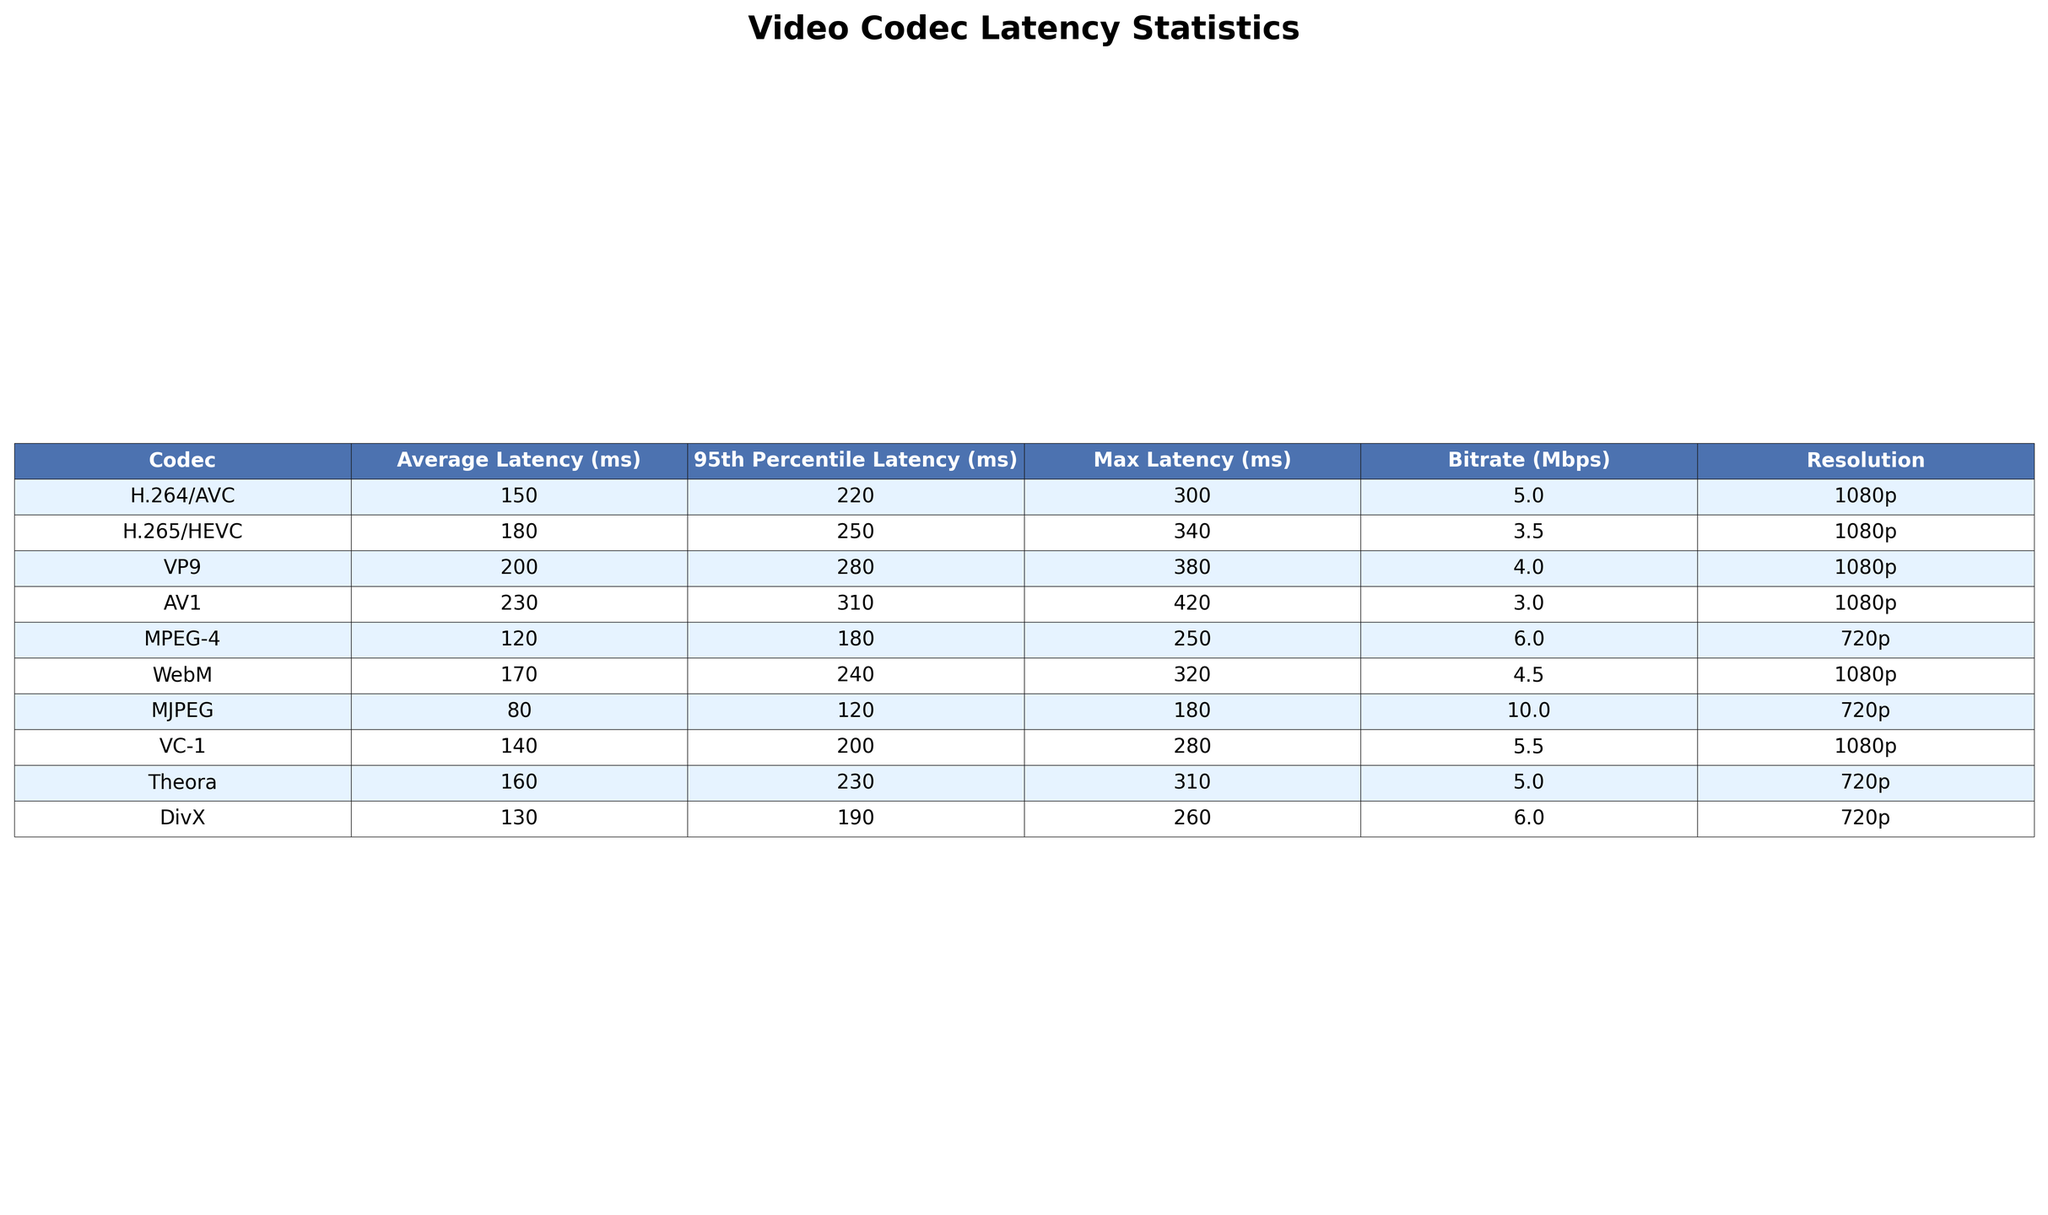What is the average latency of the H.265 codec? The average latency for the H.265 codec is provided in the table under the 'Average Latency (ms)' column. It is listed as 180 ms.
Answer: 180 ms Which codec has the maximum latency among the listed codecs? The maximum latency for each codec is listed under the 'Max Latency (ms)' column. The highest value is 420 ms, which corresponds to the AV1 codec.
Answer: AV1 What is the difference in average latency between H.264 and VP9? The average latency for H.264 is 150 ms, and for VP9, it is 200 ms. The difference is 200 ms - 150 ms = 50 ms.
Answer: 50 ms Is the average latency of the WebM codec less than 200 ms? The average latency for the WebM codec is 170 ms, which is less than 200 ms, so the answer is true.
Answer: Yes Which codec shows the highest 95th percentile latency? The '95th Percentile Latency (ms)' column shows that AV1 has the highest value of 310 ms.
Answer: AV1 What is the average bitrate of all the codecs listed in the table? First, we sum all the bitrates: 5 + 3.5 + 4 + 3 + 6 + 4.5 + 10 + 5.5 + 5 + 6 = 58. Then we divide by the number of codecs, which is 10. Thus, the average bitrate is 58 / 10 = 5.8 Mbps.
Answer: 5.8 Mbps Which codecs have a maximum latency greater than 300 ms? We check the 'Max Latency (ms)' column for values greater than 300 ms and find that the VP9 (380 ms) and AV1 (420 ms) codecs qualify.
Answer: VP9 and AV1 How many codecs have an average latency below 160 ms? We look at the 'Average Latency (ms)' column to see which values are below 160 ms: H.264 (150 ms) and MJPEG (80 ms) fall into this category. Thus, there are 2 codecs.
Answer: 2 codecs What is the average resolution of the codecs that have an average latency above 200 ms? The codecs with latencies above 200 ms are VP9 (1080p), AV1 (1080p), and Theora (720p). The average resolution can be considered as a categorical average, which is predominantly 1080p in 2 out of 3 cases (more than 50%).
Answer: Mostly 1080p Does the H.264 codec produce a higher average latency compared to the Theora codec? The average latency for H.264 is 150 ms and for Theora, it is 160 ms. Since 150 ms is less than 160 ms, the answer is false.
Answer: No 